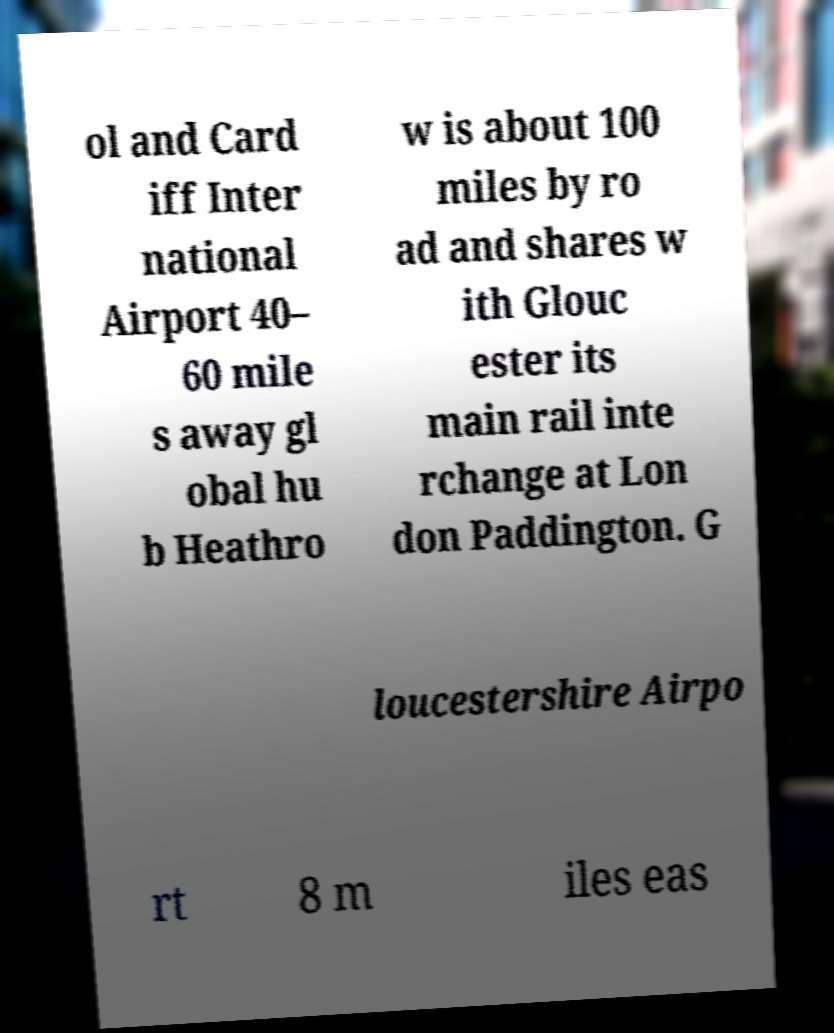What messages or text are displayed in this image? I need them in a readable, typed format. ol and Card iff Inter national Airport 40– 60 mile s away gl obal hu b Heathro w is about 100 miles by ro ad and shares w ith Glouc ester its main rail inte rchange at Lon don Paddington. G loucestershire Airpo rt 8 m iles eas 